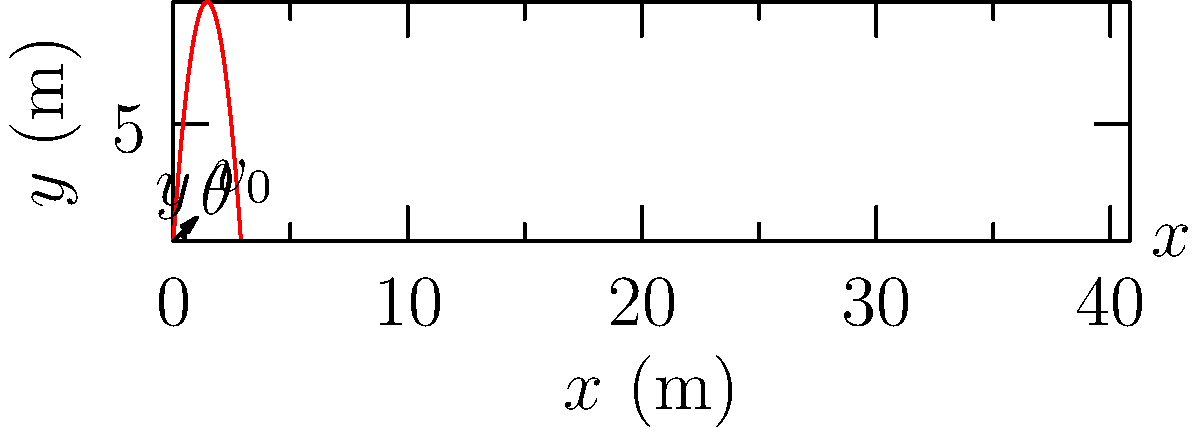In a traditional racquetball court, a player hits the ball with an initial velocity of $20 \text{ m/s}$ at an angle of $45^\circ$ above the horizontal. Assuming no air resistance, calculate the maximum height reached by the ball. Round your answer to the nearest centimeter. To solve this problem, we'll use the equations of motion for projectile motion:

1) First, we need to find the time it takes for the ball to reach its maximum height. At this point, the vertical velocity is zero.

   $v_y = v_0 \sin \theta - gt = 0$
   
   Where $v_0 = 20 \text{ m/s}$, $\theta = 45^\circ$, and $g = 9.8 \text{ m/s}^2$

2) Solving for $t$:
   
   $t = \frac{v_0 \sin \theta}{g} = \frac{20 \sin 45^\circ}{9.8} = \frac{20 \cdot 0.707}{9.8} = 1.44 \text{ s}$

3) Now we can use the equation for vertical displacement:

   $y = v_0 \sin \theta \cdot t - \frac{1}{2}gt^2$

4) Substituting our values:

   $y = 20 \sin 45^\circ \cdot 1.44 - \frac{1}{2} \cdot 9.8 \cdot 1.44^2$
   
   $y = 20 \cdot 0.707 \cdot 1.44 - 4.9 \cdot 2.07$
   
   $y = 20.36 - 10.14 = 10.22 \text{ m}$

5) Rounding to the nearest centimeter:

   $y = 10.22 \text{ m} = 1022 \text{ cm}$

Therefore, the maximum height reached by the ball is 1022 cm or 10.22 m.
Answer: 1022 cm 